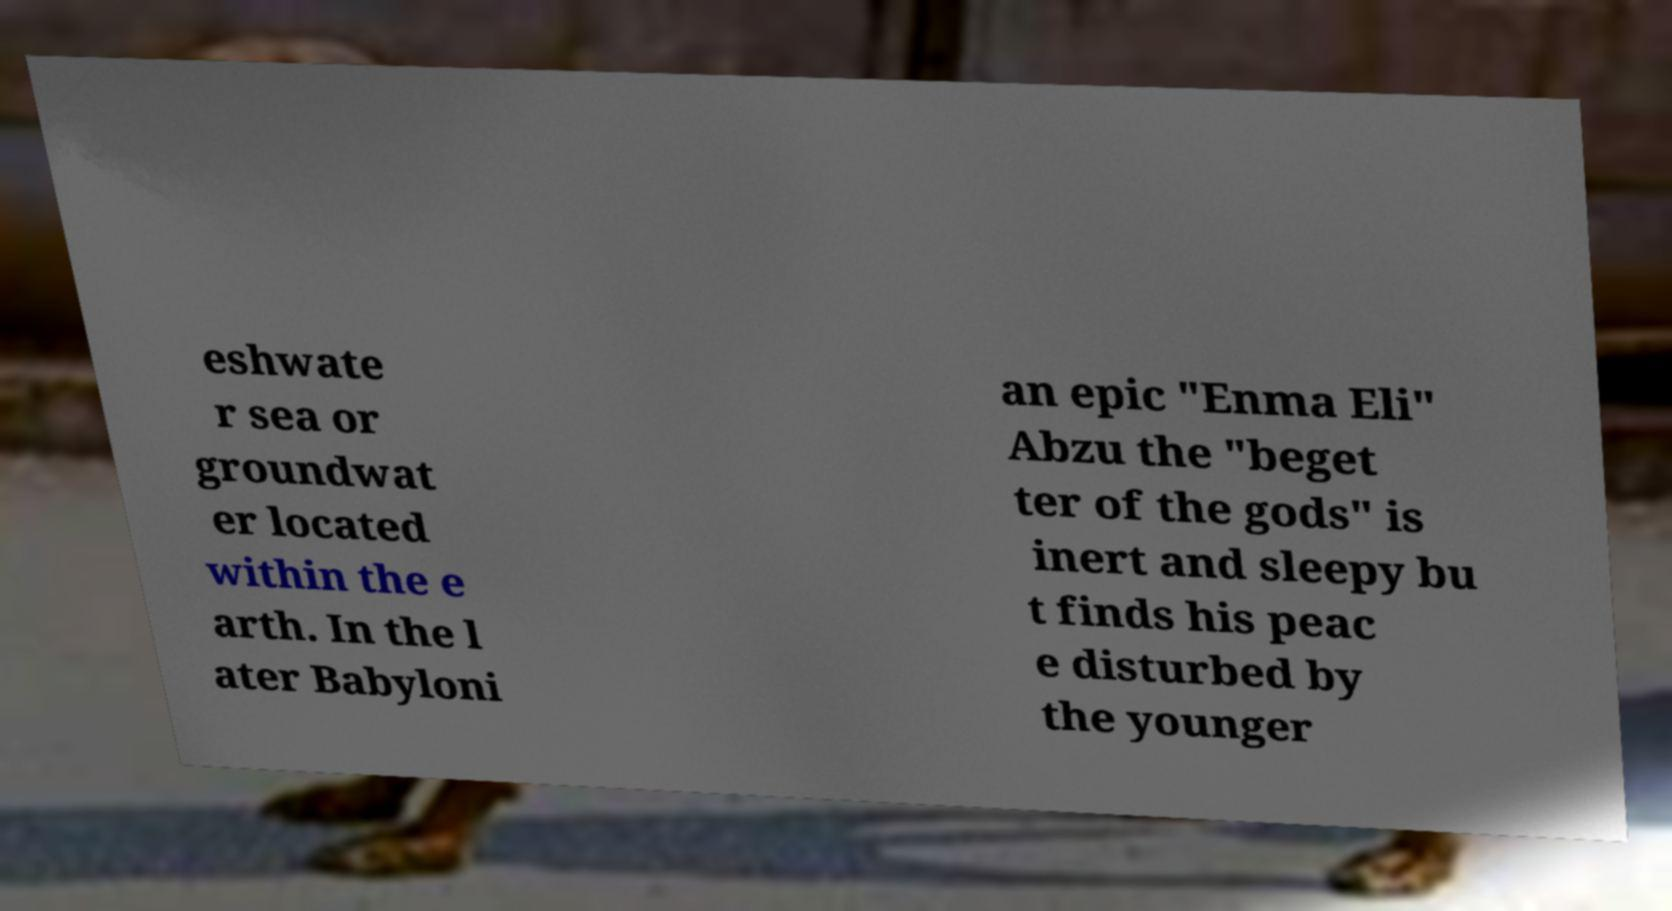Can you accurately transcribe the text from the provided image for me? eshwate r sea or groundwat er located within the e arth. In the l ater Babyloni an epic "Enma Eli" Abzu the "beget ter of the gods" is inert and sleepy bu t finds his peac e disturbed by the younger 